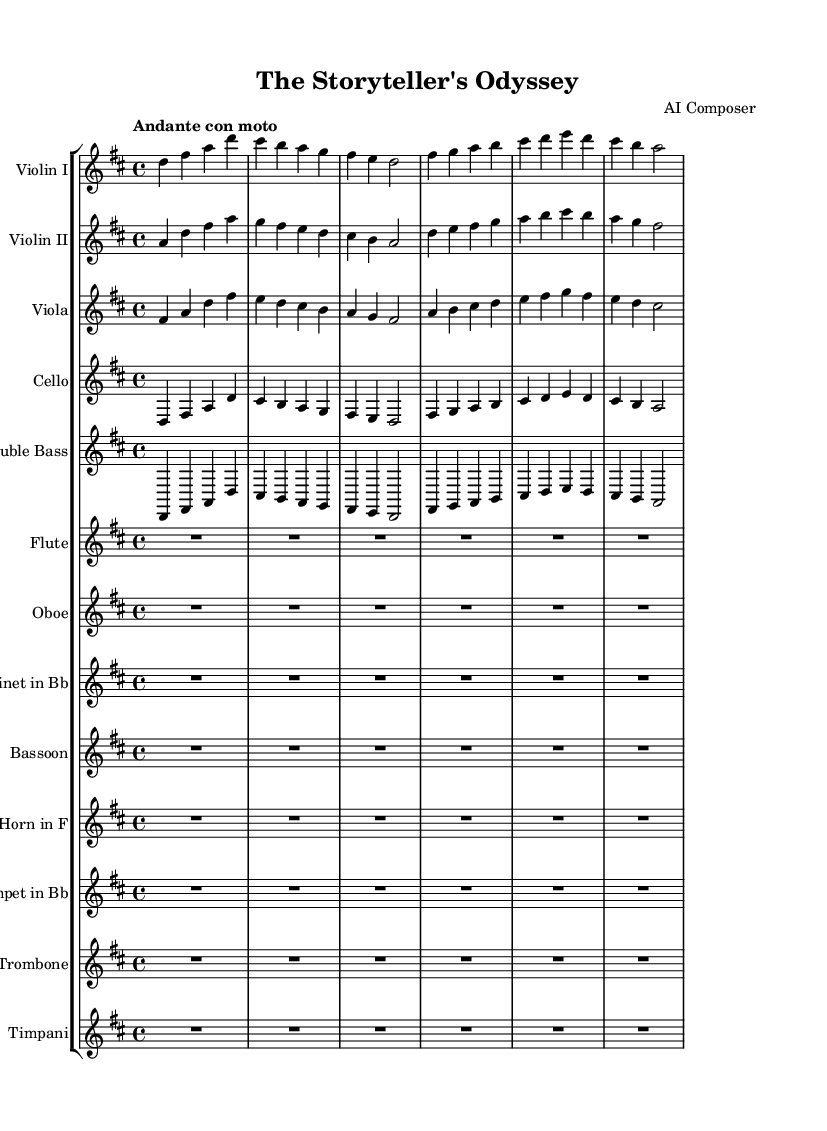What is the key signature of this music? The key signature is indicated at the beginning of the staff. The one sharp indicates that the key is D major.
Answer: D major What is the time signature of this music? The time signature is displayed at the start of the staff, and it shows a 4/4. This means there are four beats in a measure and the quarter note gets one beat.
Answer: 4/4 What is the tempo marking for this piece? The tempo marking appears at the beginning, stating "Andante con moto," which indicates a moderately slow speed with a bit of movement.
Answer: Andante con moto How many different instruments are used in this composition? The score shows a total of 12 different staff systems, one for each instrument, indicating the variety of instruments used in the composition.
Answer: 12 Which instrument has no notes written in the score? The Flute, Oboe, Clarinet, Bassoon, Horn, Trumpet, Trombone, and Timpani all have rests (R1*6), indicating they are silent for this section. However, looking closely, they all appear to have no notes written.
Answer: Flute, Oboe, Clarinet, Bassoon, Horn, Trumpet, Trombone, Timpani Based on the structure, what is the primary section being portrayed in this piece? The repetitive sequences in sections for Violin I, Violin II, Viola, Cello, and Double Bass reflect thematic development typical of symphonic storytelling. This indicates that the piece is likely portraying a narrative through its melodic themes.
Answer: Thematic development Identify the predominant instrument group in this composition. The strings are represented by Violin I, Violin II, Viola, Cello, and Double Bass, appearing prominently in the score, showing their central role in orchestration.
Answer: Strings 